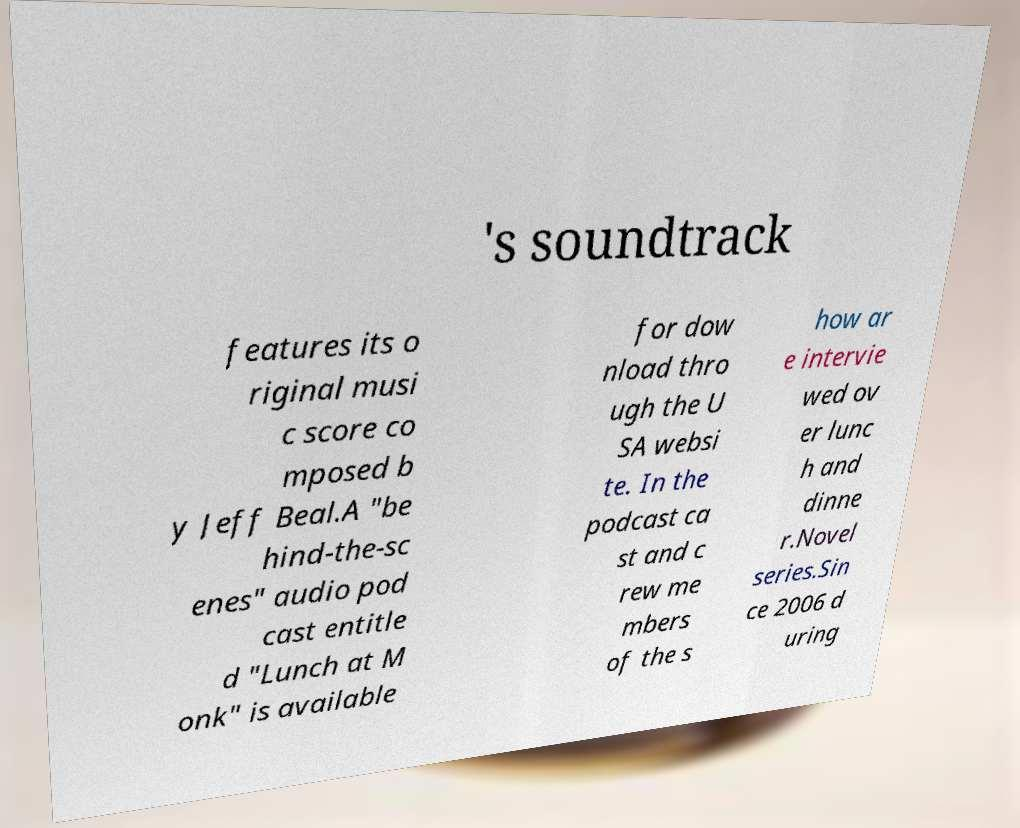Could you assist in decoding the text presented in this image and type it out clearly? 's soundtrack features its o riginal musi c score co mposed b y Jeff Beal.A "be hind-the-sc enes" audio pod cast entitle d "Lunch at M onk" is available for dow nload thro ugh the U SA websi te. In the podcast ca st and c rew me mbers of the s how ar e intervie wed ov er lunc h and dinne r.Novel series.Sin ce 2006 d uring 